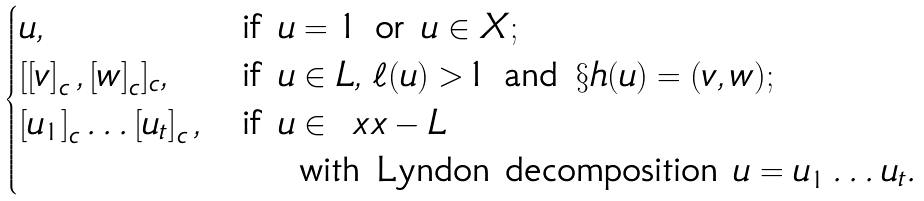Convert formula to latex. <formula><loc_0><loc_0><loc_500><loc_500>\begin{cases} u , & \text {if } u = 1 \text { or } u \in X ; \\ [ \left [ v \right ] _ { c } , \left [ w \right ] _ { c } ] _ { c } , & \text {if } u \in L , \, \ell ( u ) > 1 \text { and } \S h ( u ) = ( v , w ) ; \\ \left [ u _ { 1 } \right ] _ { c } \dots \left [ u _ { t } \right ] _ { c } , & \text {if } u \in \ x x - L \\ & \quad \text { with Lyndon decomposition } u = u _ { 1 } \dots u _ { t } . \\ \end{cases}</formula> 